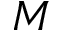Convert formula to latex. <formula><loc_0><loc_0><loc_500><loc_500>M</formula> 